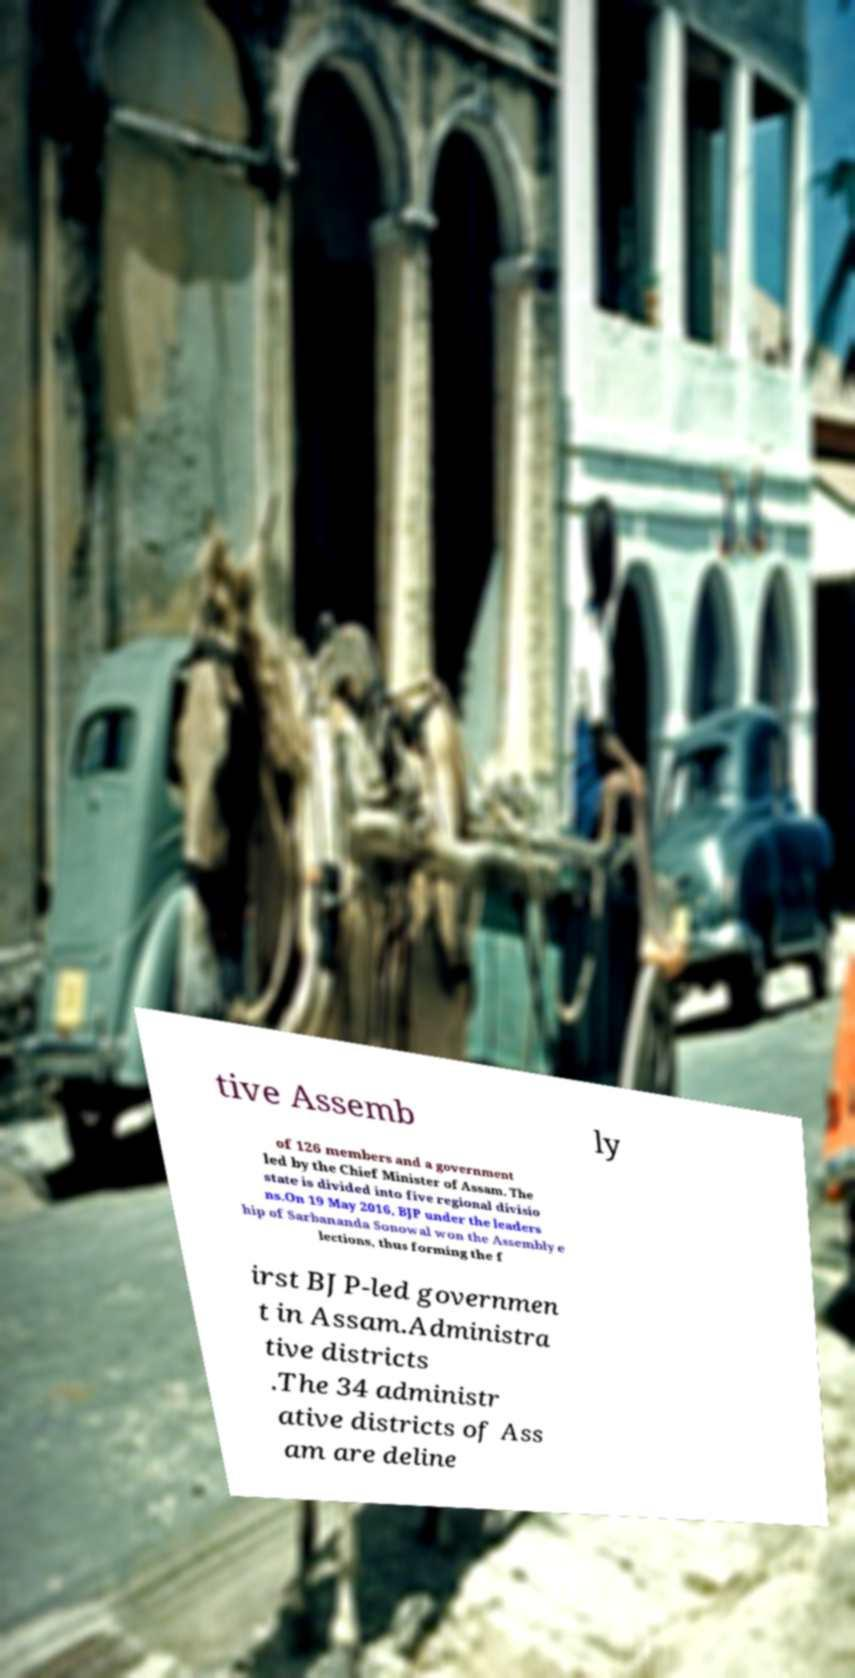Please identify and transcribe the text found in this image. tive Assemb ly of 126 members and a government led by the Chief Minister of Assam. The state is divided into five regional divisio ns.On 19 May 2016, BJP under the leaders hip of Sarbananda Sonowal won the Assembly e lections, thus forming the f irst BJP-led governmen t in Assam.Administra tive districts .The 34 administr ative districts of Ass am are deline 